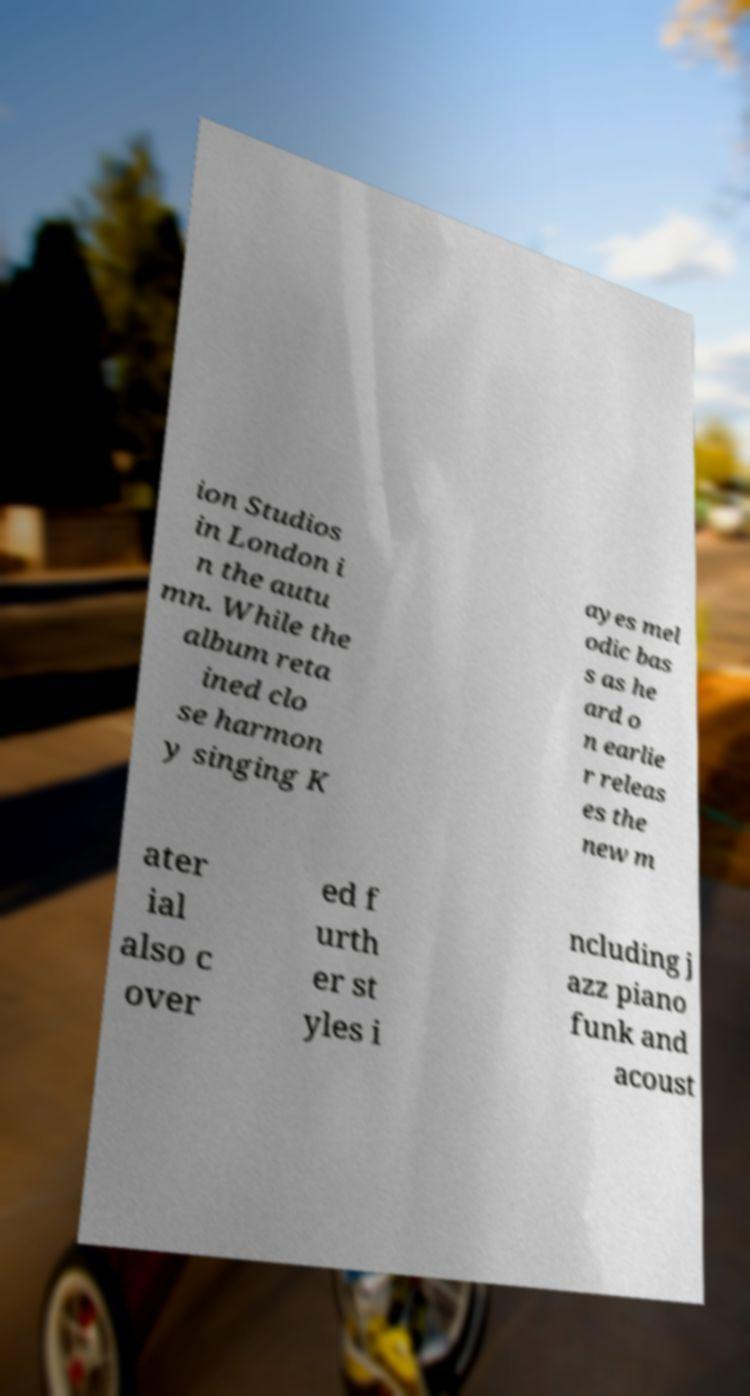Can you accurately transcribe the text from the provided image for me? ion Studios in London i n the autu mn. While the album reta ined clo se harmon y singing K ayes mel odic bas s as he ard o n earlie r releas es the new m ater ial also c over ed f urth er st yles i ncluding j azz piano funk and acoust 